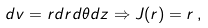Convert formula to latex. <formula><loc_0><loc_0><loc_500><loc_500>d v = r d r d \theta d z \Rightarrow J ( r ) = r \, ,</formula> 